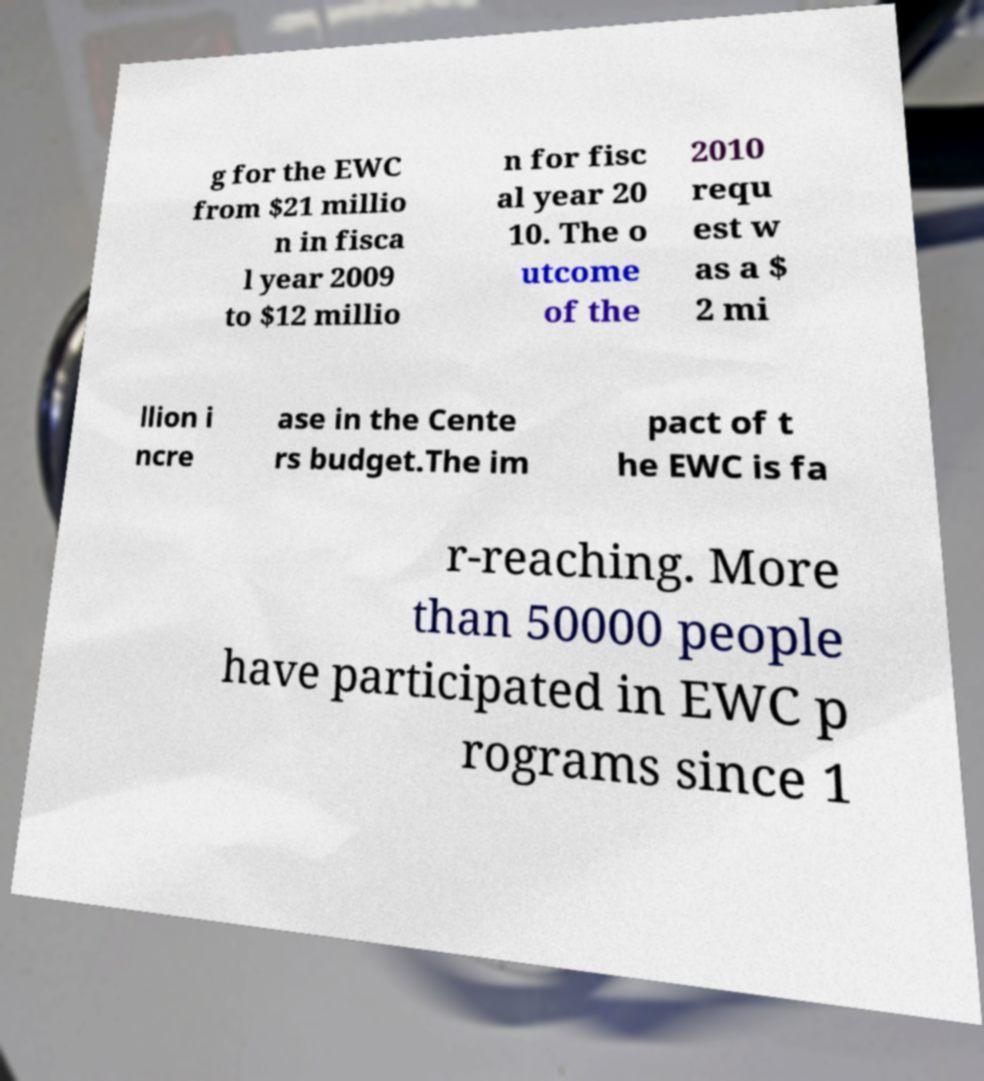Can you read and provide the text displayed in the image?This photo seems to have some interesting text. Can you extract and type it out for me? g for the EWC from $21 millio n in fisca l year 2009 to $12 millio n for fisc al year 20 10. The o utcome of the 2010 requ est w as a $ 2 mi llion i ncre ase in the Cente rs budget.The im pact of t he EWC is fa r-reaching. More than 50000 people have participated in EWC p rograms since 1 